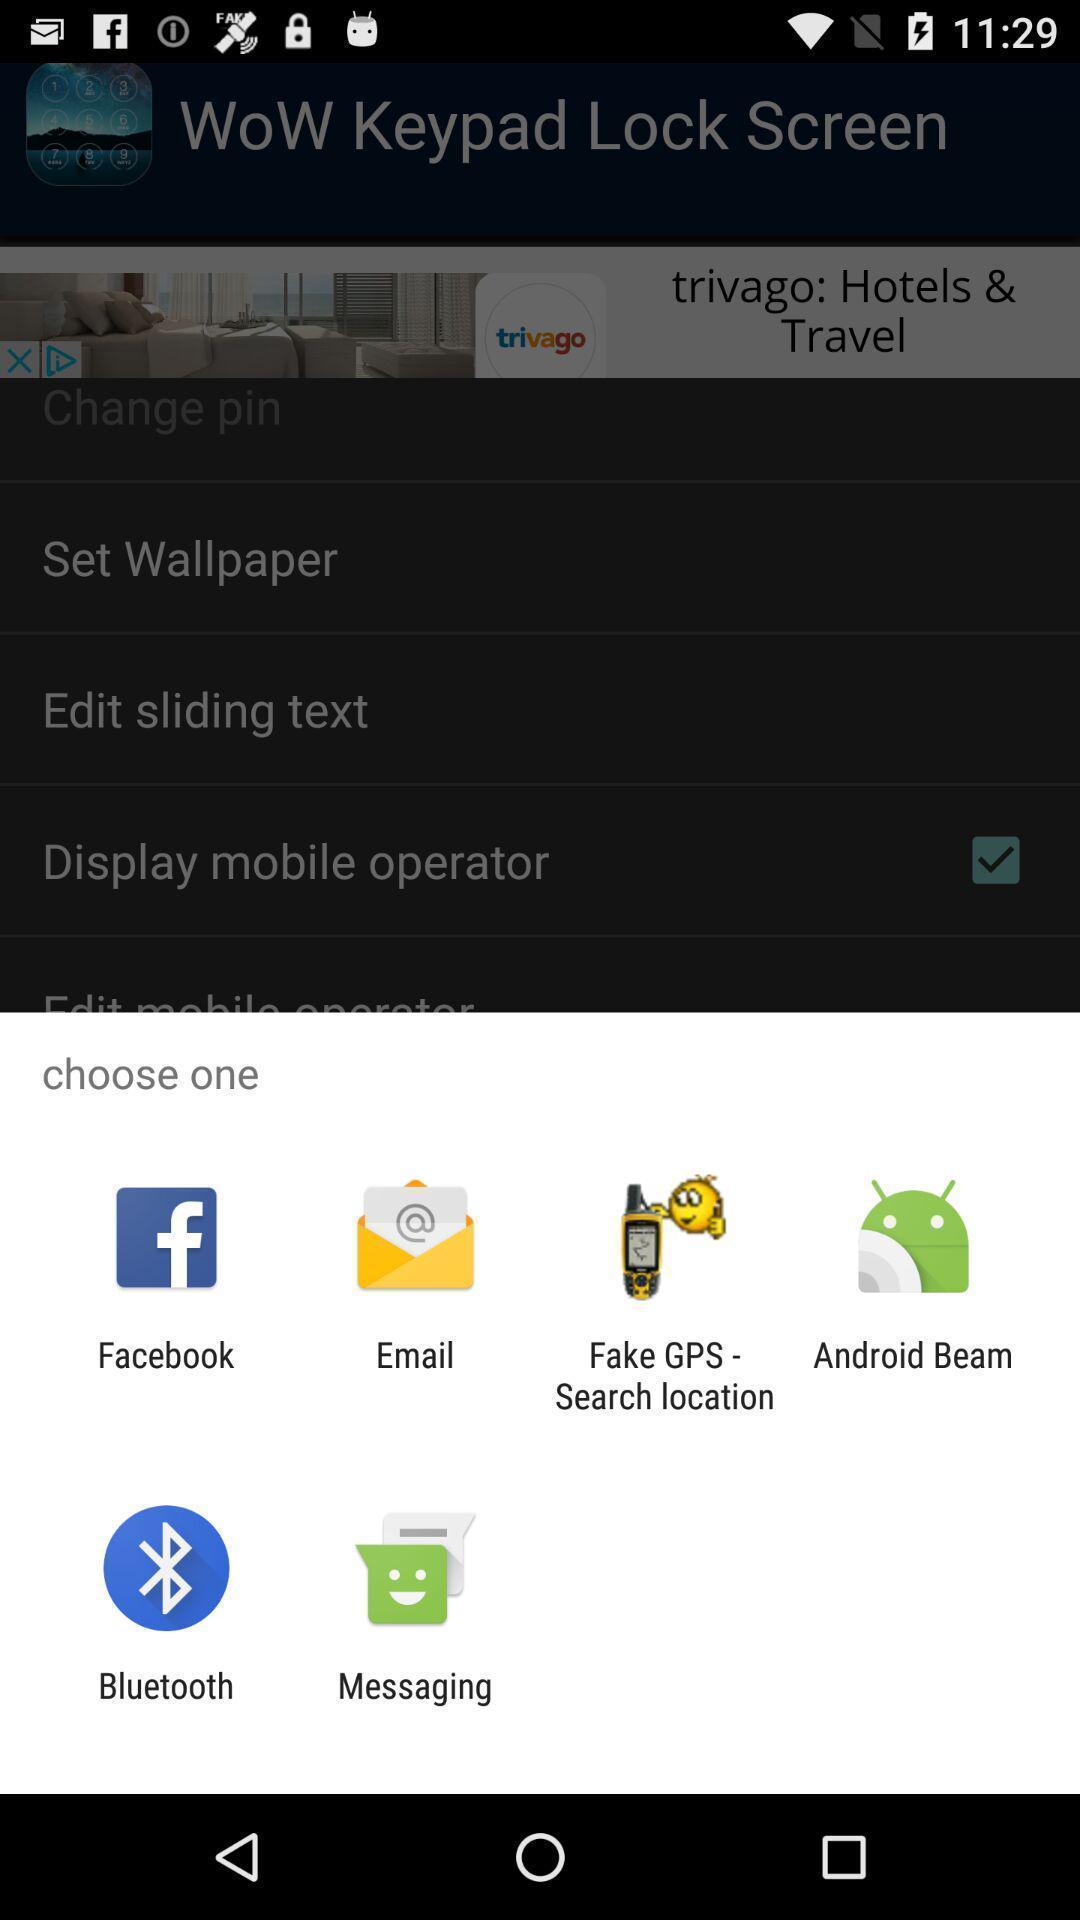Give me a narrative description of this picture. Pop-up showing different options to choose. 